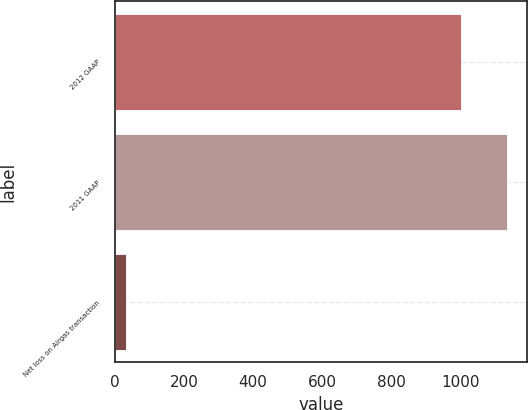Convert chart to OTSL. <chart><loc_0><loc_0><loc_500><loc_500><bar_chart><fcel>2012 GAAP<fcel>2011 GAAP<fcel>Net loss on Airgas transaction<nl><fcel>999.2<fcel>1134.3<fcel>31.6<nl></chart> 